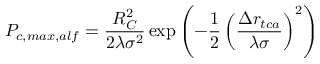Convert formula to latex. <formula><loc_0><loc_0><loc_500><loc_500>P _ { c , \max , a l f } = \frac { R _ { C } ^ { 2 } } { 2 \lambda \sigma ^ { 2 } } \exp { \left ( - \frac { 1 } { 2 } \left ( \frac { \Delta r _ { t c a } } { \lambda \sigma } \right ) ^ { 2 } \right ) }</formula> 